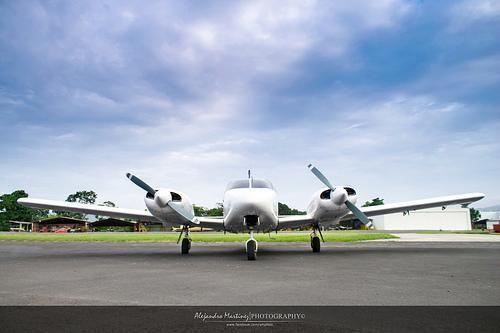How many airplanes are there?
Give a very brief answer. 1. 